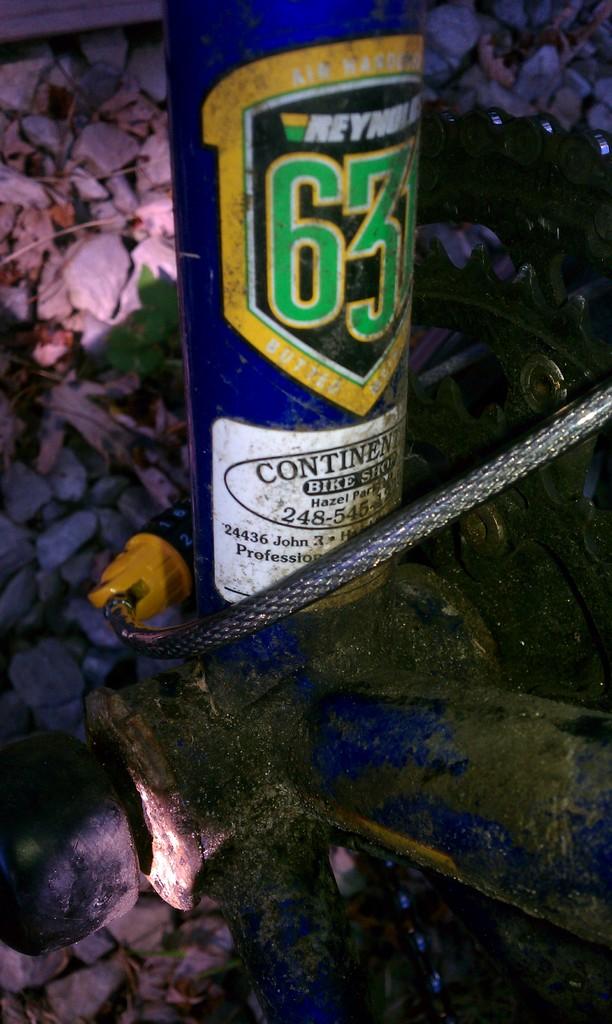What number is on this?
Provide a succinct answer. 63. 